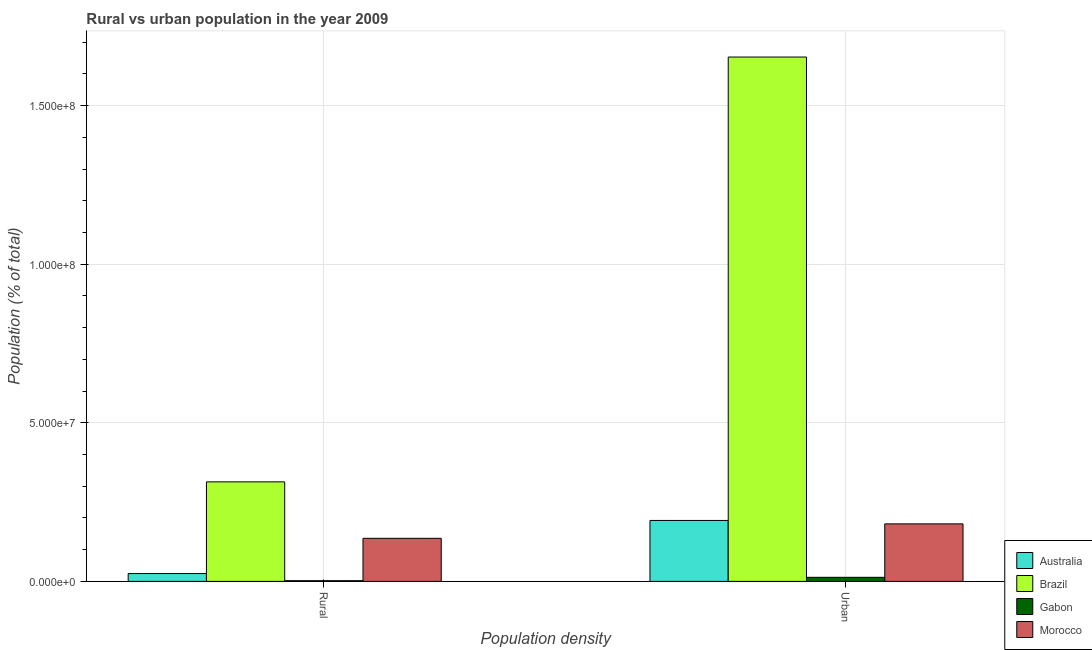How many different coloured bars are there?
Ensure brevity in your answer.  4. Are the number of bars on each tick of the X-axis equal?
Offer a very short reply. Yes. How many bars are there on the 2nd tick from the right?
Offer a terse response. 4. What is the label of the 1st group of bars from the left?
Make the answer very short. Rural. What is the urban population density in Brazil?
Offer a terse response. 1.65e+08. Across all countries, what is the maximum rural population density?
Ensure brevity in your answer.  3.14e+07. Across all countries, what is the minimum rural population density?
Your answer should be very brief. 2.21e+05. In which country was the rural population density maximum?
Your answer should be compact. Brazil. In which country was the urban population density minimum?
Your response must be concise. Gabon. What is the total urban population density in the graph?
Give a very brief answer. 2.04e+08. What is the difference between the urban population density in Morocco and that in Gabon?
Provide a succinct answer. 1.68e+07. What is the difference between the rural population density in Brazil and the urban population density in Australia?
Provide a short and direct response. 1.22e+07. What is the average rural population density per country?
Offer a terse response. 1.19e+07. What is the difference between the urban population density and rural population density in Morocco?
Provide a succinct answer. 4.55e+06. In how many countries, is the rural population density greater than 110000000 %?
Keep it short and to the point. 0. What is the ratio of the urban population density in Brazil to that in Gabon?
Your answer should be very brief. 128.55. Is the rural population density in Gabon less than that in Morocco?
Make the answer very short. Yes. What does the 1st bar from the left in Urban represents?
Your response must be concise. Australia. How many countries are there in the graph?
Keep it short and to the point. 4. Are the values on the major ticks of Y-axis written in scientific E-notation?
Ensure brevity in your answer.  Yes. Does the graph contain any zero values?
Give a very brief answer. No. Does the graph contain grids?
Ensure brevity in your answer.  Yes. Where does the legend appear in the graph?
Ensure brevity in your answer.  Bottom right. How many legend labels are there?
Your answer should be compact. 4. What is the title of the graph?
Offer a terse response. Rural vs urban population in the year 2009. What is the label or title of the X-axis?
Your response must be concise. Population density. What is the label or title of the Y-axis?
Your response must be concise. Population (% of total). What is the Population (% of total) of Australia in Rural?
Your response must be concise. 2.48e+06. What is the Population (% of total) of Brazil in Rural?
Offer a very short reply. 3.14e+07. What is the Population (% of total) in Gabon in Rural?
Give a very brief answer. 2.21e+05. What is the Population (% of total) in Morocco in Rural?
Your answer should be compact. 1.36e+07. What is the Population (% of total) in Australia in Urban?
Keep it short and to the point. 1.92e+07. What is the Population (% of total) in Brazil in Urban?
Offer a terse response. 1.65e+08. What is the Population (% of total) in Gabon in Urban?
Give a very brief answer. 1.29e+06. What is the Population (% of total) in Morocco in Urban?
Offer a terse response. 1.81e+07. Across all Population density, what is the maximum Population (% of total) of Australia?
Provide a short and direct response. 1.92e+07. Across all Population density, what is the maximum Population (% of total) of Brazil?
Your answer should be compact. 1.65e+08. Across all Population density, what is the maximum Population (% of total) of Gabon?
Your answer should be very brief. 1.29e+06. Across all Population density, what is the maximum Population (% of total) in Morocco?
Ensure brevity in your answer.  1.81e+07. Across all Population density, what is the minimum Population (% of total) of Australia?
Your response must be concise. 2.48e+06. Across all Population density, what is the minimum Population (% of total) of Brazil?
Your answer should be very brief. 3.14e+07. Across all Population density, what is the minimum Population (% of total) of Gabon?
Provide a short and direct response. 2.21e+05. Across all Population density, what is the minimum Population (% of total) of Morocco?
Your answer should be very brief. 1.36e+07. What is the total Population (% of total) of Australia in the graph?
Ensure brevity in your answer.  2.17e+07. What is the total Population (% of total) in Brazil in the graph?
Offer a very short reply. 1.97e+08. What is the total Population (% of total) of Gabon in the graph?
Your answer should be compact. 1.51e+06. What is the total Population (% of total) in Morocco in the graph?
Ensure brevity in your answer.  3.17e+07. What is the difference between the Population (% of total) of Australia in Rural and that in Urban?
Keep it short and to the point. -1.67e+07. What is the difference between the Population (% of total) of Brazil in Rural and that in Urban?
Make the answer very short. -1.34e+08. What is the difference between the Population (% of total) of Gabon in Rural and that in Urban?
Give a very brief answer. -1.06e+06. What is the difference between the Population (% of total) of Morocco in Rural and that in Urban?
Offer a terse response. -4.55e+06. What is the difference between the Population (% of total) of Australia in Rural and the Population (% of total) of Brazil in Urban?
Keep it short and to the point. -1.63e+08. What is the difference between the Population (% of total) of Australia in Rural and the Population (% of total) of Gabon in Urban?
Your response must be concise. 1.19e+06. What is the difference between the Population (% of total) in Australia in Rural and the Population (% of total) in Morocco in Urban?
Make the answer very short. -1.57e+07. What is the difference between the Population (% of total) in Brazil in Rural and the Population (% of total) in Gabon in Urban?
Provide a short and direct response. 3.01e+07. What is the difference between the Population (% of total) of Brazil in Rural and the Population (% of total) of Morocco in Urban?
Offer a terse response. 1.33e+07. What is the difference between the Population (% of total) of Gabon in Rural and the Population (% of total) of Morocco in Urban?
Your answer should be compact. -1.79e+07. What is the average Population (% of total) of Australia per Population density?
Offer a very short reply. 1.08e+07. What is the average Population (% of total) in Brazil per Population density?
Give a very brief answer. 9.84e+07. What is the average Population (% of total) of Gabon per Population density?
Give a very brief answer. 7.54e+05. What is the average Population (% of total) in Morocco per Population density?
Offer a very short reply. 1.59e+07. What is the difference between the Population (% of total) of Australia and Population (% of total) of Brazil in Rural?
Your response must be concise. -2.89e+07. What is the difference between the Population (% of total) in Australia and Population (% of total) in Gabon in Rural?
Your answer should be very brief. 2.25e+06. What is the difference between the Population (% of total) of Australia and Population (% of total) of Morocco in Rural?
Your response must be concise. -1.11e+07. What is the difference between the Population (% of total) in Brazil and Population (% of total) in Gabon in Rural?
Your answer should be very brief. 3.12e+07. What is the difference between the Population (% of total) in Brazil and Population (% of total) in Morocco in Rural?
Offer a terse response. 1.78e+07. What is the difference between the Population (% of total) in Gabon and Population (% of total) in Morocco in Rural?
Provide a short and direct response. -1.34e+07. What is the difference between the Population (% of total) in Australia and Population (% of total) in Brazil in Urban?
Give a very brief answer. -1.46e+08. What is the difference between the Population (% of total) in Australia and Population (% of total) in Gabon in Urban?
Ensure brevity in your answer.  1.79e+07. What is the difference between the Population (% of total) in Australia and Population (% of total) in Morocco in Urban?
Provide a short and direct response. 1.08e+06. What is the difference between the Population (% of total) in Brazil and Population (% of total) in Gabon in Urban?
Give a very brief answer. 1.64e+08. What is the difference between the Population (% of total) of Brazil and Population (% of total) of Morocco in Urban?
Your answer should be very brief. 1.47e+08. What is the difference between the Population (% of total) in Gabon and Population (% of total) in Morocco in Urban?
Make the answer very short. -1.68e+07. What is the ratio of the Population (% of total) in Australia in Rural to that in Urban?
Your response must be concise. 0.13. What is the ratio of the Population (% of total) of Brazil in Rural to that in Urban?
Keep it short and to the point. 0.19. What is the ratio of the Population (% of total) of Gabon in Rural to that in Urban?
Ensure brevity in your answer.  0.17. What is the ratio of the Population (% of total) in Morocco in Rural to that in Urban?
Give a very brief answer. 0.75. What is the difference between the highest and the second highest Population (% of total) in Australia?
Keep it short and to the point. 1.67e+07. What is the difference between the highest and the second highest Population (% of total) of Brazil?
Offer a very short reply. 1.34e+08. What is the difference between the highest and the second highest Population (% of total) in Gabon?
Offer a very short reply. 1.06e+06. What is the difference between the highest and the second highest Population (% of total) in Morocco?
Make the answer very short. 4.55e+06. What is the difference between the highest and the lowest Population (% of total) of Australia?
Keep it short and to the point. 1.67e+07. What is the difference between the highest and the lowest Population (% of total) of Brazil?
Keep it short and to the point. 1.34e+08. What is the difference between the highest and the lowest Population (% of total) in Gabon?
Your answer should be very brief. 1.06e+06. What is the difference between the highest and the lowest Population (% of total) in Morocco?
Provide a short and direct response. 4.55e+06. 